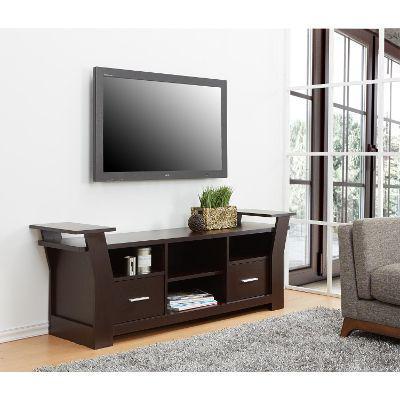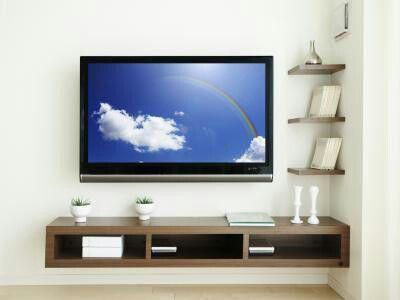The first image is the image on the left, the second image is the image on the right. Assess this claim about the two images: "One of the images shows a TV that is not mounted to the wall.". Correct or not? Answer yes or no. No. The first image is the image on the left, the second image is the image on the right. For the images displayed, is the sentence "At least one image shows some type of green plant near a flat-screen TV, and exactly one image contains a TV with a picture on its screen." factually correct? Answer yes or no. Yes. 